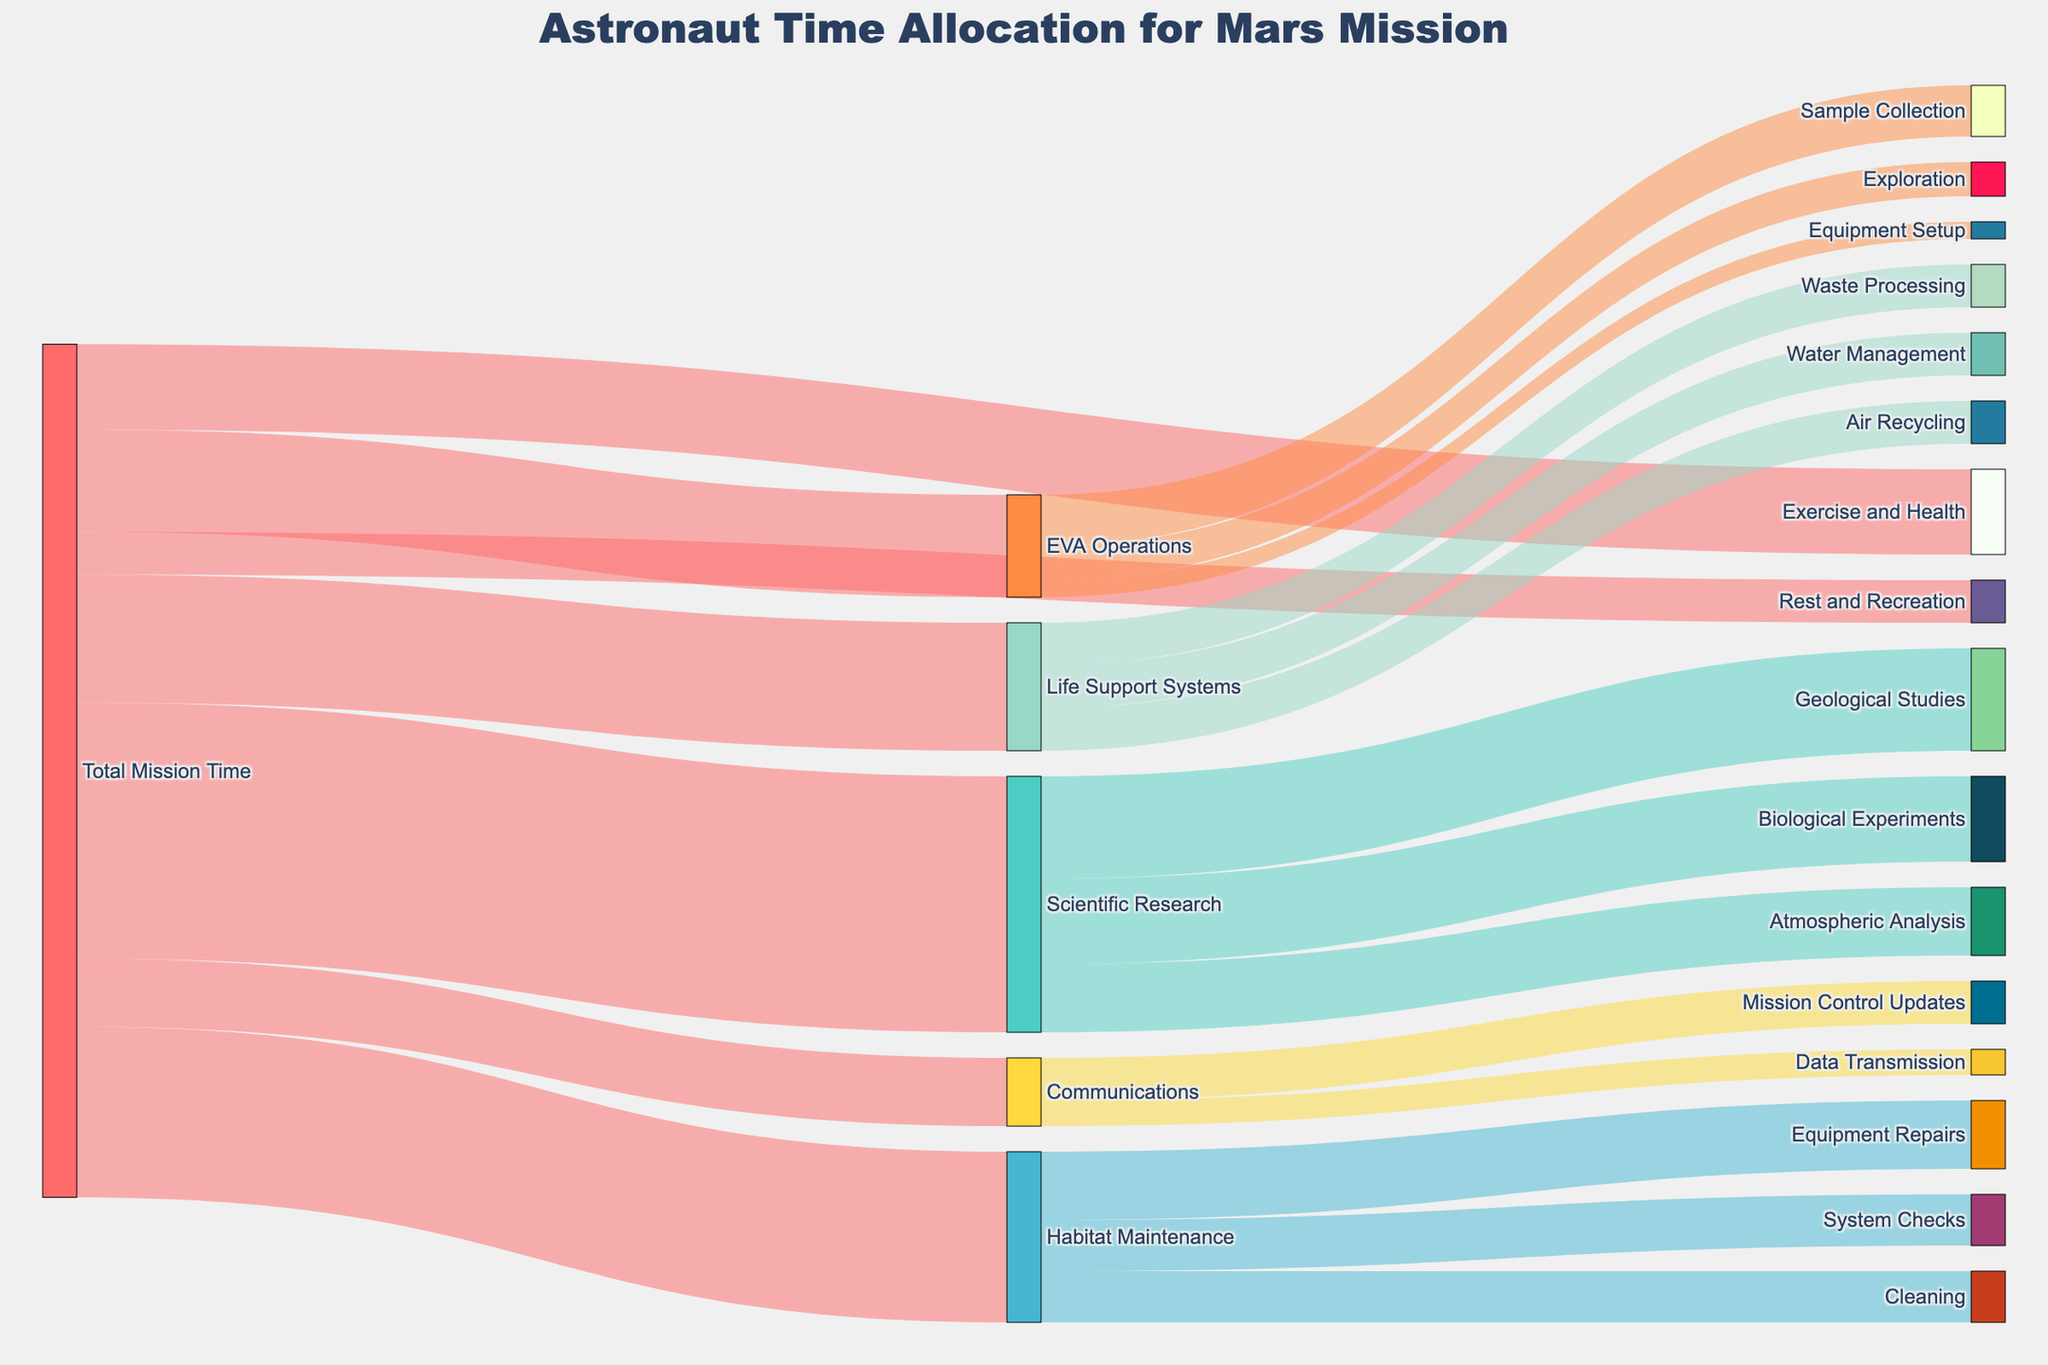What is the main title of the diagram? The main title of the diagram is displayed at the top and provides an overview of what the figure represents.
Answer: Astronaut Time Allocation for Mars Mission Which task uses the most of the Total Mission Time? By observing the thickness of the flows and the labels, we can see which task has the largest allocation from Total Mission Time.
Answer: Scientific Research How much time is spent on Habitat Maintenance activities combined? We need to sum the values of all activities under Habitat Maintenance: Equipment Repairs (8), Cleaning (6), and System Checks (6). So, 8 + 6 + 6 = 20.
Answer: 20 What is the difference in time allocation between Exercise and Health and Rest and Recreation? Exercise and Health is allocated 10 units of time, and Rest and Recreation has 5 units. The difference is 10 - 5.
Answer: 5 Which activity under Life Support Systems has the same amount of time allocated as Air Recycling? By comparing the values under Life Support Systems, Air Recycling (5), Water Management (5), and Waste Processing (5), we see the same allocation.
Answer: Water Management and Waste Processing How does the time allocated to Communications compare to EVA Operations? Communications has 8 units, and EVA Operations has 12 units. We can compare these values directly to see which is greater.
Answer: EVA Operations Identify all sub-activities under EVA Operations. By tracing the flows from EVA Operations, we find the sub-activities Sample Collection, Exploration, and Equipment Setup.
Answer: Sample Collection, Exploration, Equipment Setup Which activity related to Scientific Research takes the least time? Observing the flows from Scientific Research, we compare Geological Studies (12), Atmospheric Analysis (8), and Biological Experiments (10). The least allocation is Atmospheric Analysis.
Answer: Atmospheric Analysis What percentage of Total Mission Time is allocated to Communications? To find the percentage, divide the time for Communications (8) by the Total Mission Time and multiply by 100. Total = 100, so (8/100) * 100.
Answer: 8% What is the combined time spent on all activities under Scientific Research? Adding the values for Geological Studies (12), Atmospheric Analysis (8), and Biological Experiments (10), we get 12 + 8 + 10 = 30.
Answer: 30 